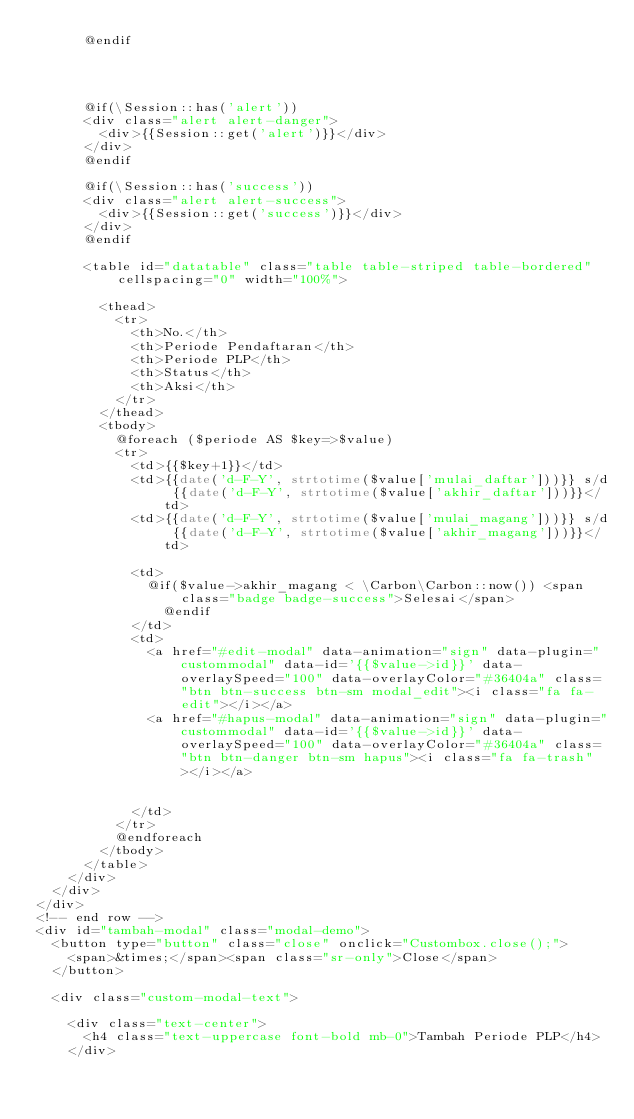Convert code to text. <code><loc_0><loc_0><loc_500><loc_500><_PHP_>      @endif




      @if(\Session::has('alert'))
      <div class="alert alert-danger">
        <div>{{Session::get('alert')}}</div>
      </div>
      @endif

      @if(\Session::has('success'))
      <div class="alert alert-success">
        <div>{{Session::get('success')}}</div>
      </div>
      @endif

      <table id="datatable" class="table table-striped table-bordered" cellspacing="0" width="100%">

        <thead>
          <tr>
            <th>No.</th>
            <th>Periode Pendaftaran</th>
            <th>Periode PLP</th>
            <th>Status</th>
            <th>Aksi</th>
          </tr>
        </thead>
        <tbody>
          @foreach ($periode AS $key=>$value)
          <tr>
            <td>{{$key+1}}</td>
            <td>{{date('d-F-Y', strtotime($value['mulai_daftar']))}} s/d {{date('d-F-Y', strtotime($value['akhir_daftar']))}}</td>
            <td>{{date('d-F-Y', strtotime($value['mulai_magang']))}} s/d {{date('d-F-Y', strtotime($value['akhir_magang']))}}</td>

            <td>
              @if($value->akhir_magang < \Carbon\Carbon::now()) <span class="badge badge-success">Selesai</span>
                @endif
            </td>
            <td>
              <a href="#edit-modal" data-animation="sign" data-plugin="custommodal" data-id='{{$value->id}}' data-overlaySpeed="100" data-overlayColor="#36404a" class="btn btn-success btn-sm modal_edit"><i class="fa fa-edit"></i></a>
              <a href="#hapus-modal" data-animation="sign" data-plugin="custommodal" data-id='{{$value->id}}' data-overlaySpeed="100" data-overlayColor="#36404a" class="btn btn-danger btn-sm hapus"><i class="fa fa-trash"></i></a>


            </td>
          </tr>
          @endforeach
        </tbody>
      </table>
    </div>
  </div>
</div>
<!-- end row -->
<div id="tambah-modal" class="modal-demo">
  <button type="button" class="close" onclick="Custombox.close();">
    <span>&times;</span><span class="sr-only">Close</span>
  </button>

  <div class="custom-modal-text">

    <div class="text-center">
      <h4 class="text-uppercase font-bold mb-0">Tambah Periode PLP</h4>
    </div></code> 